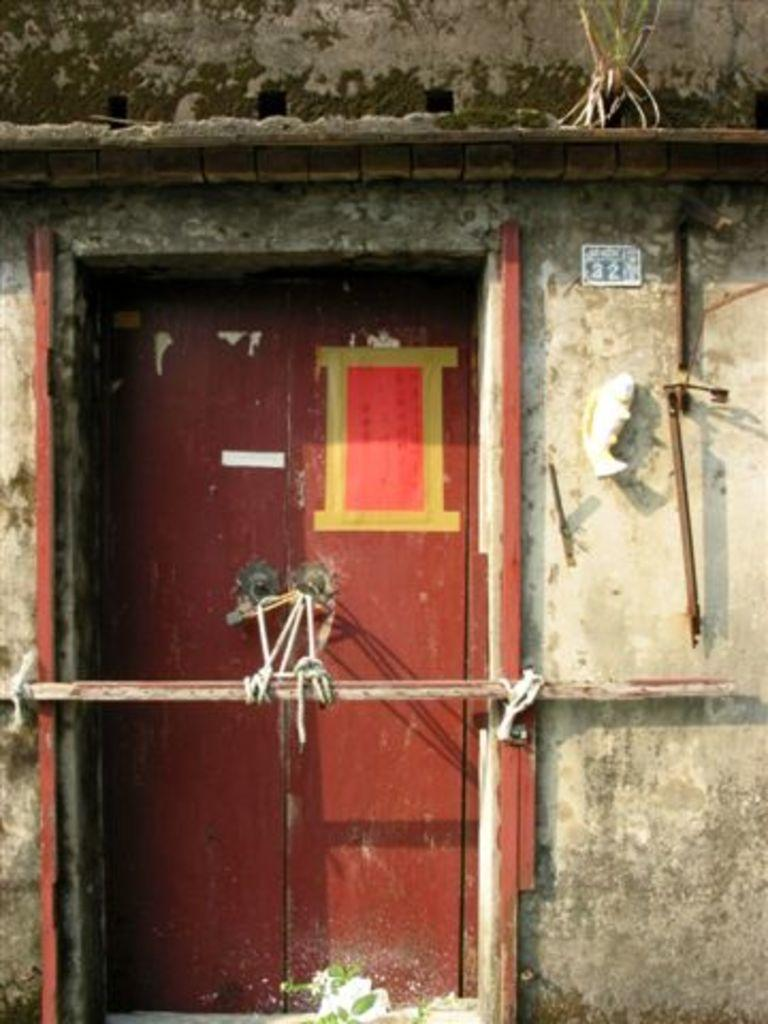What type of structure is present in the image? There is a shed in the image. Can you describe the door of the shed? The shed has a door in the center, and it is tied with ropes. What can be seen on the wall on the right side of the shed? There are rods placed on the wall on the right side of the shed. What type of cemetery can be seen in the image? There is no cemetery present in the image; it features a shed with a door and rods on the wall. How many railway tracks are visible in the image? There are no railway tracks visible in the image. 